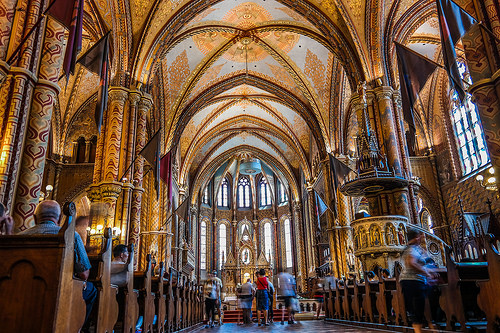<image>
Is there a man in front of the bench? No. The man is not in front of the bench. The spatial positioning shows a different relationship between these objects. 